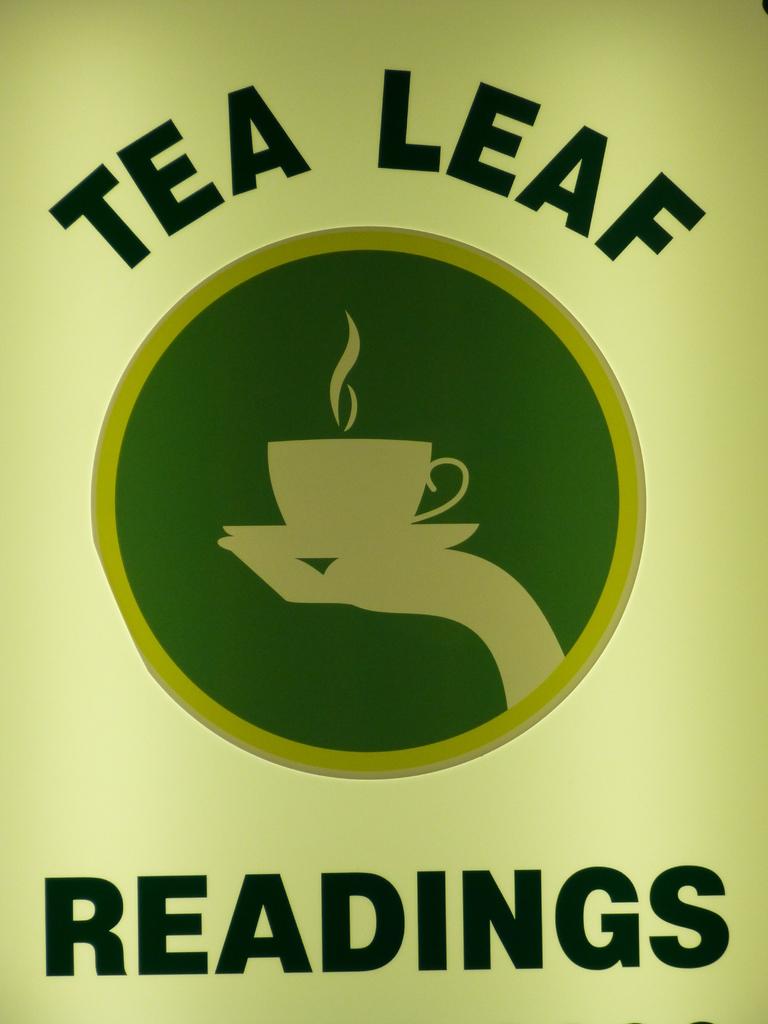What kind of readings are advertised?
Ensure brevity in your answer.  Tea leaf. 